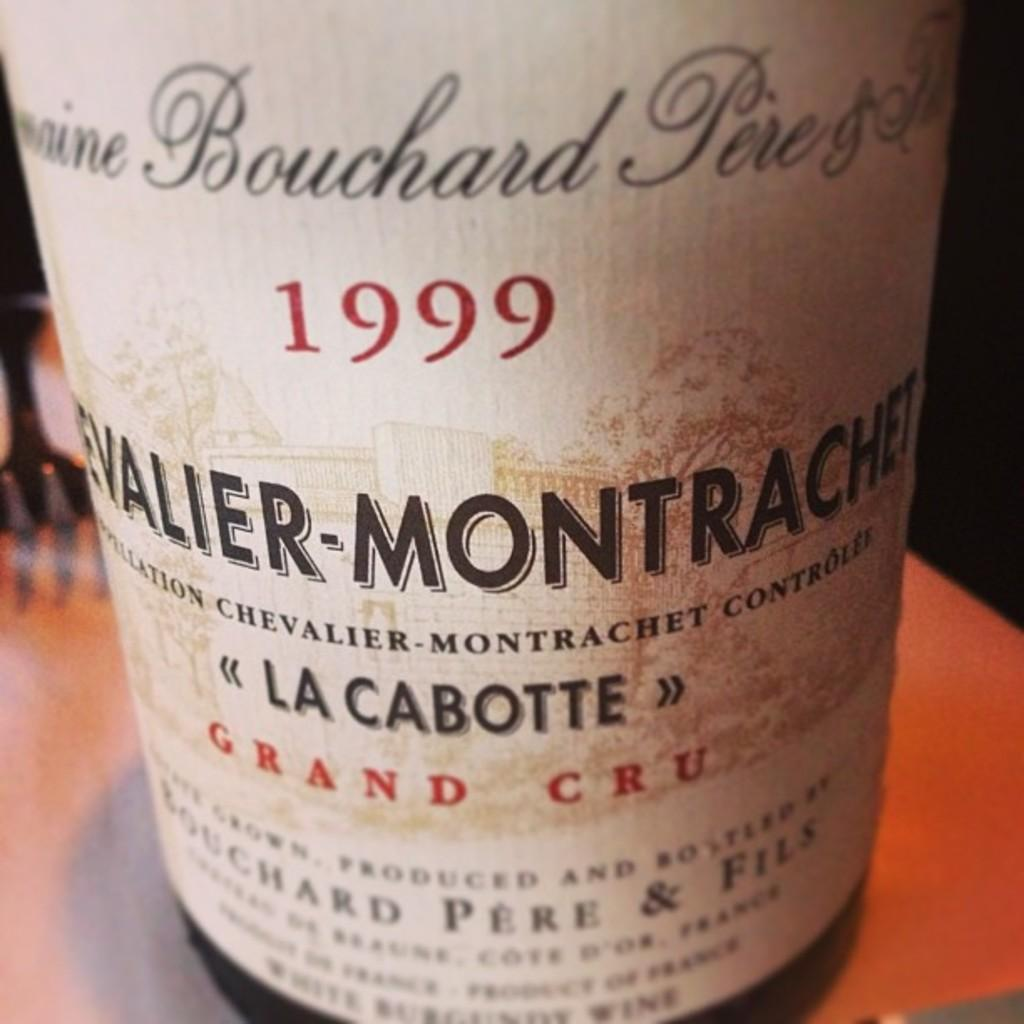<image>
Render a clear and concise summary of the photo. A close up of a 1999 La Cabotte label 